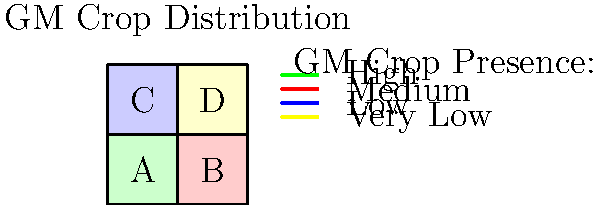Based on the map visualization of genetically modified (GM) crop distribution, which region shows the highest presence of GM crops, and what strategy would you recommend for monitoring the potential spread to adjacent areas? To answer this question, we need to analyze the map and consider monitoring strategies:

1. Interpret the map:
   - Region A (green): Indicates high GM crop presence
   - Region B (red): Indicates medium GM crop presence
   - Region C (blue): Indicates low GM crop presence
   - Region D (yellow): Indicates very low GM crop presence

2. Identify the region with the highest GM crop presence:
   - Region A has the highest presence of GM crops (green)

3. Consider monitoring strategies for adjacent areas:
   - Focus on the borders between Region A and its neighbors (B and C)
   - Implement buffer zones along these borders
   - Conduct regular sampling and testing in adjacent regions
   - Use remote sensing and GIS technologies for large-scale monitoring
   - Establish a reporting system for farmers in neighboring regions
   - Collaborate with local agricultural extension services for data collection

4. Prioritize monitoring efforts:
   - Allocate more resources to monitoring the border between A and C (low presence)
   - Monitor the border between A and B (medium presence) with moderate intensity
   - Conduct periodic checks in Region D to ensure no unexpected spread

The recommended strategy would be to implement a comprehensive monitoring program focusing on buffer zones and regular testing, with emphasis on the borders between Region A and its neighbors, especially the transition to the low-presence Region C.
Answer: Region A; implement buffer zones and regular testing at borders, prioritizing A-C transition. 